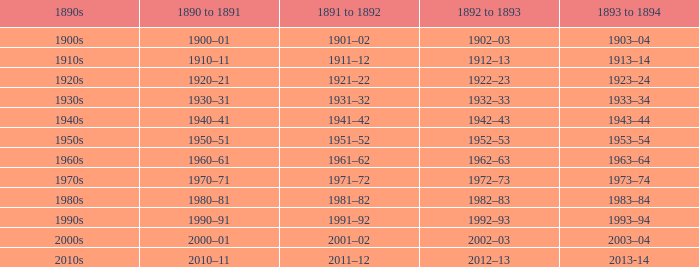What is the year from 1891-92 from the years 1890s to the 1960s? 1961–62. 